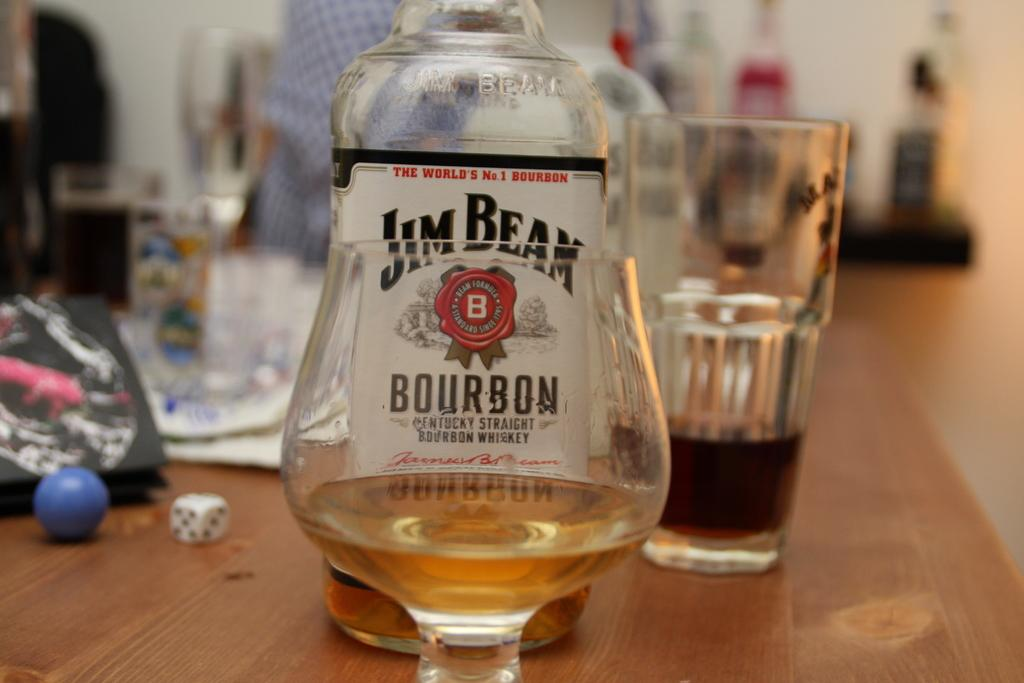<image>
Create a compact narrative representing the image presented. A glass containing golden liquid sits in front of a Jim beam bottle. 